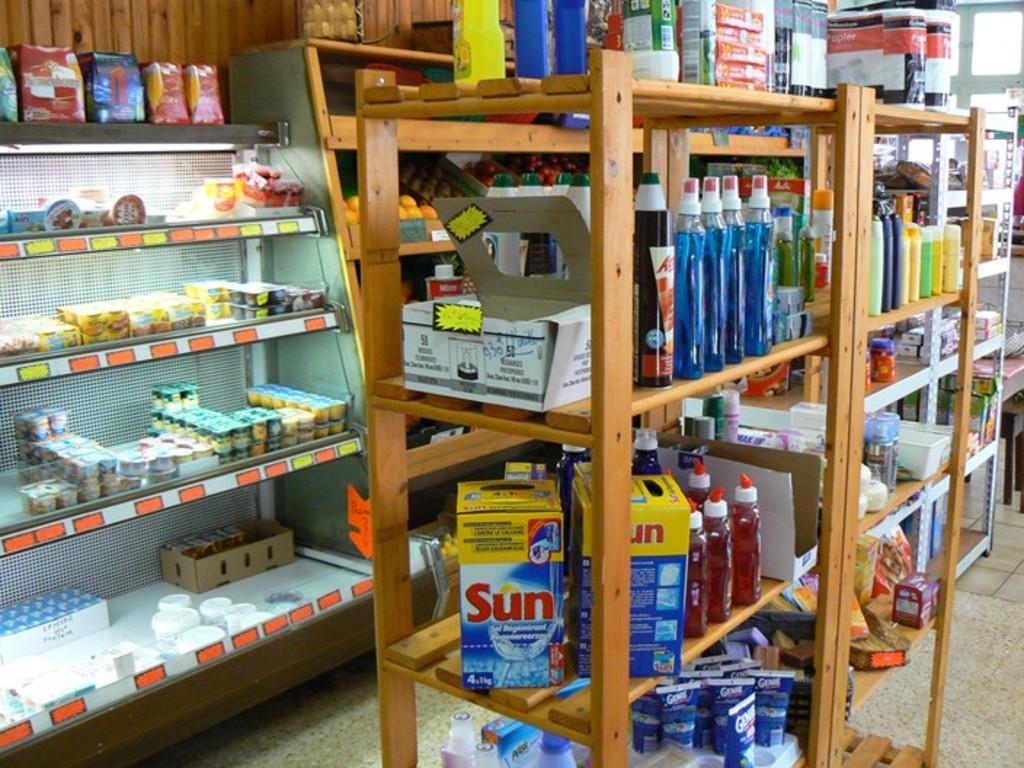What brand of detergent is being sold?
Keep it short and to the point. Sun. 